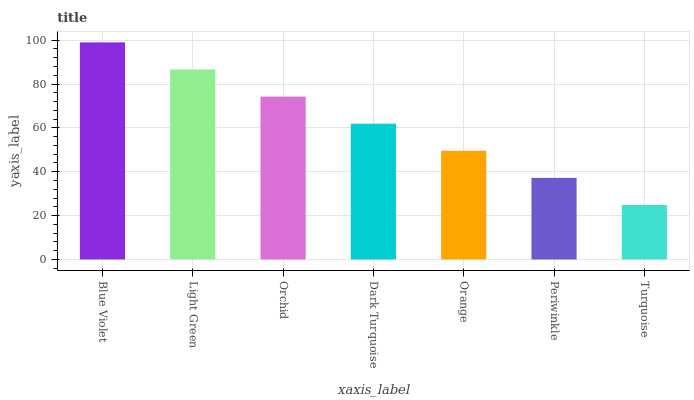Is Turquoise the minimum?
Answer yes or no. Yes. Is Blue Violet the maximum?
Answer yes or no. Yes. Is Light Green the minimum?
Answer yes or no. No. Is Light Green the maximum?
Answer yes or no. No. Is Blue Violet greater than Light Green?
Answer yes or no. Yes. Is Light Green less than Blue Violet?
Answer yes or no. Yes. Is Light Green greater than Blue Violet?
Answer yes or no. No. Is Blue Violet less than Light Green?
Answer yes or no. No. Is Dark Turquoise the high median?
Answer yes or no. Yes. Is Dark Turquoise the low median?
Answer yes or no. Yes. Is Orchid the high median?
Answer yes or no. No. Is Orchid the low median?
Answer yes or no. No. 